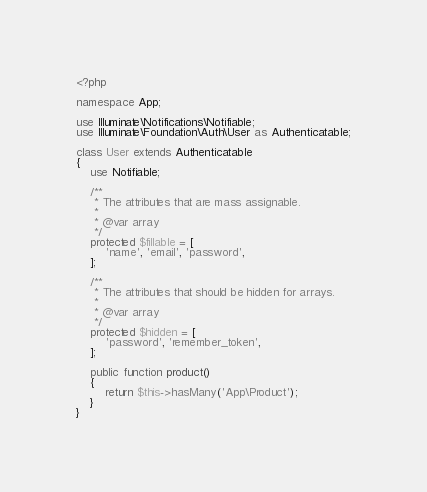Convert code to text. <code><loc_0><loc_0><loc_500><loc_500><_PHP_><?php

namespace App;

use Illuminate\Notifications\Notifiable;
use Illuminate\Foundation\Auth\User as Authenticatable;

class User extends Authenticatable
{
    use Notifiable;

    /**
     * The attributes that are mass assignable.
     *
     * @var array
     */
    protected $fillable = [
        'name', 'email', 'password',
    ];

    /**
     * The attributes that should be hidden for arrays.
     *
     * @var array
     */
    protected $hidden = [
        'password', 'remember_token',
    ];

    public function product()
    {
        return $this->hasMany('App\Product');
    }
}
</code> 